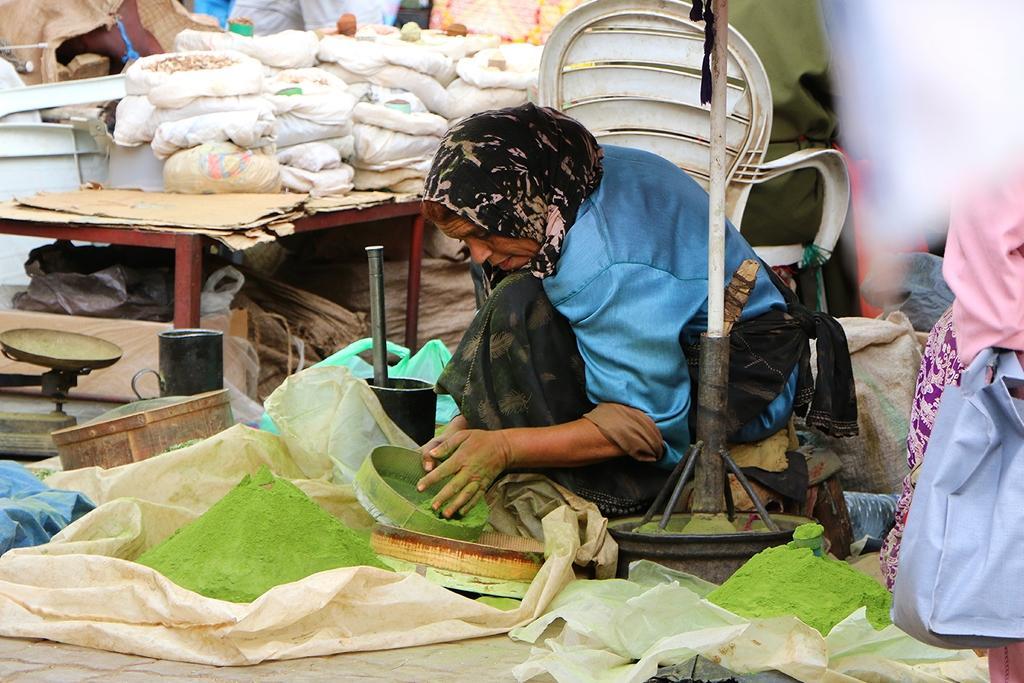Describe this image in one or two sentences. In the image we can see a woman wearing clothes and holding an object in hand. Here we can see plastic bags, a chair, pole and jute bags. 